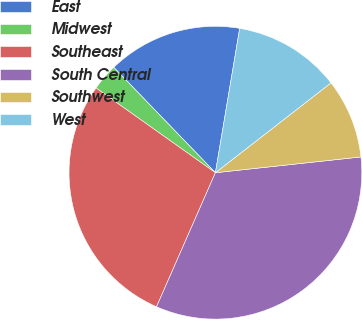<chart> <loc_0><loc_0><loc_500><loc_500><pie_chart><fcel>East<fcel>Midwest<fcel>Southeast<fcel>South Central<fcel>Southwest<fcel>West<nl><fcel>14.87%<fcel>2.96%<fcel>28.24%<fcel>33.31%<fcel>8.8%<fcel>11.83%<nl></chart> 